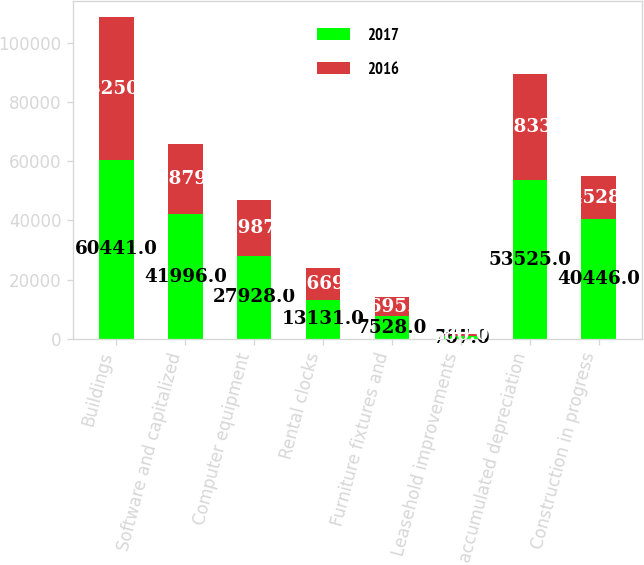<chart> <loc_0><loc_0><loc_500><loc_500><stacked_bar_chart><ecel><fcel>Buildings<fcel>Software and capitalized<fcel>Computer equipment<fcel>Rental clocks<fcel>Furniture fixtures and<fcel>Leasehold improvements<fcel>Less accumulated depreciation<fcel>Construction in progress<nl><fcel>2017<fcel>60441<fcel>41996<fcel>27928<fcel>13131<fcel>7528<fcel>767<fcel>53525<fcel>40446<nl><fcel>2016<fcel>48250<fcel>23879<fcel>18987<fcel>10669<fcel>6695<fcel>680<fcel>35833<fcel>14528<nl></chart> 